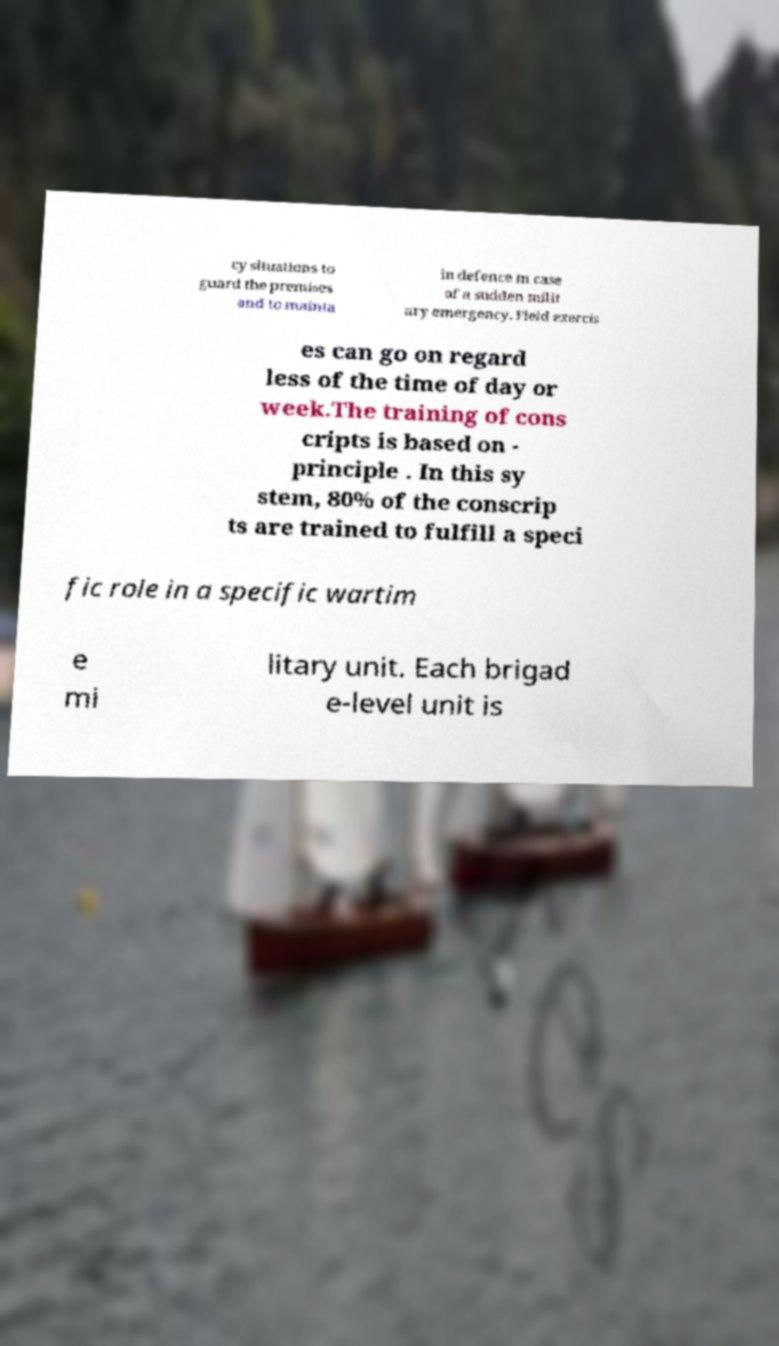Could you assist in decoding the text presented in this image and type it out clearly? cy situations to guard the premises and to mainta in defence in case of a sudden milit ary emergency. Field exercis es can go on regard less of the time of day or week.The training of cons cripts is based on - principle . In this sy stem, 80% of the conscrip ts are trained to fulfill a speci fic role in a specific wartim e mi litary unit. Each brigad e-level unit is 